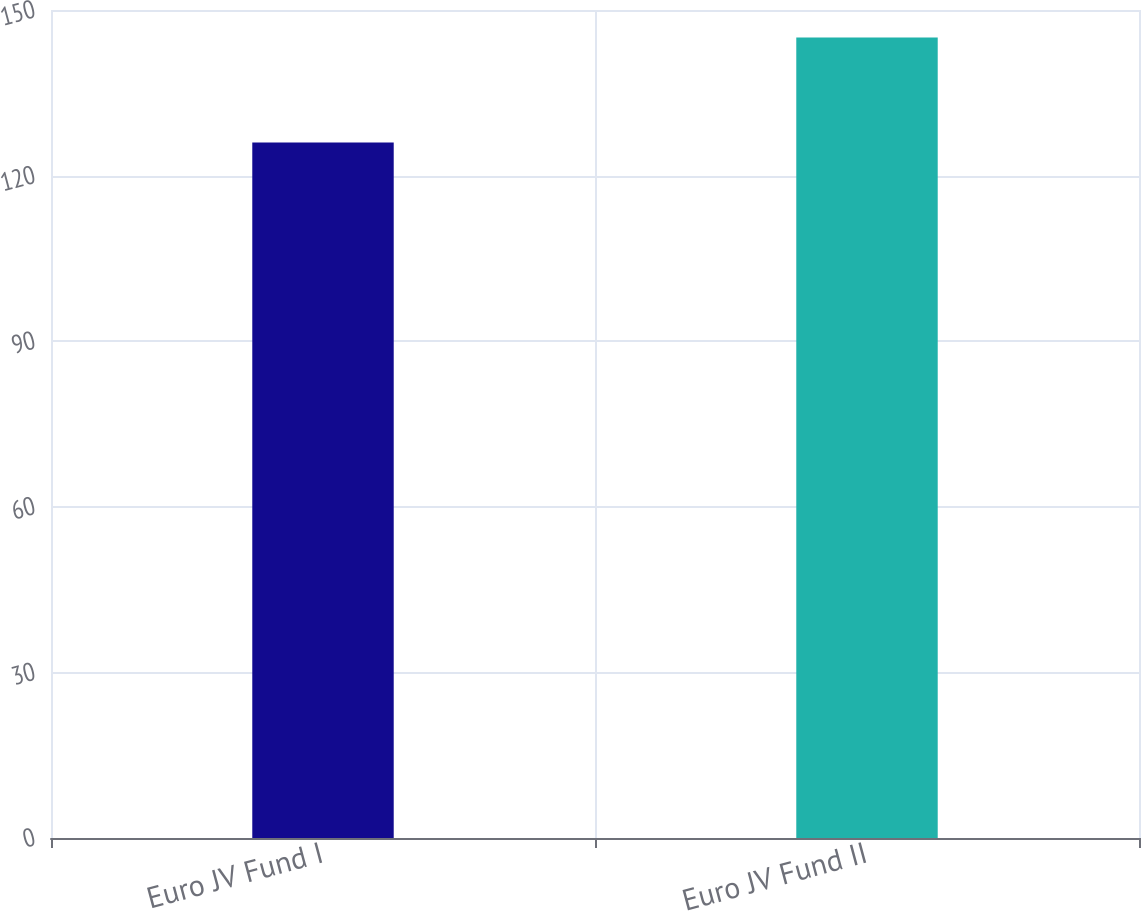Convert chart to OTSL. <chart><loc_0><loc_0><loc_500><loc_500><bar_chart><fcel>Euro JV Fund I<fcel>Euro JV Fund II<nl><fcel>126<fcel>145<nl></chart> 